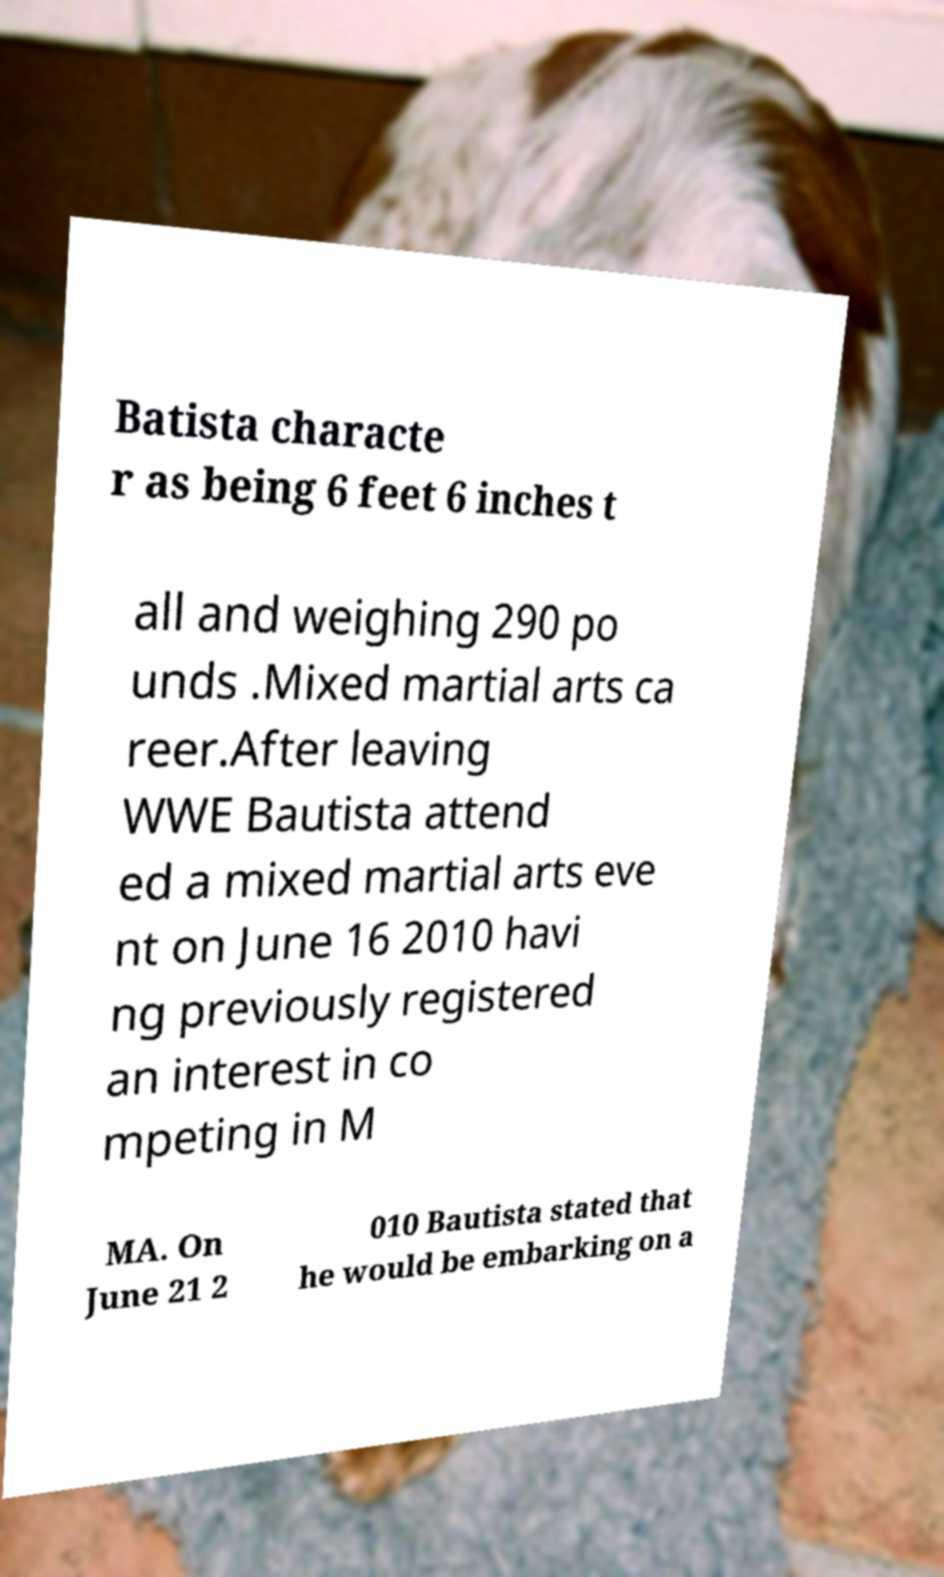Can you accurately transcribe the text from the provided image for me? Batista characte r as being 6 feet 6 inches t all and weighing 290 po unds .Mixed martial arts ca reer.After leaving WWE Bautista attend ed a mixed martial arts eve nt on June 16 2010 havi ng previously registered an interest in co mpeting in M MA. On June 21 2 010 Bautista stated that he would be embarking on a 